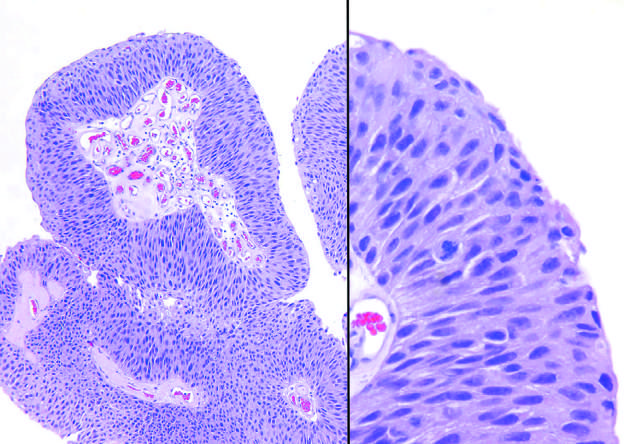what does higher magnification show with scattered mitotic figures?
Answer the question using a single word or phrase. Slightly irregular nuclei 